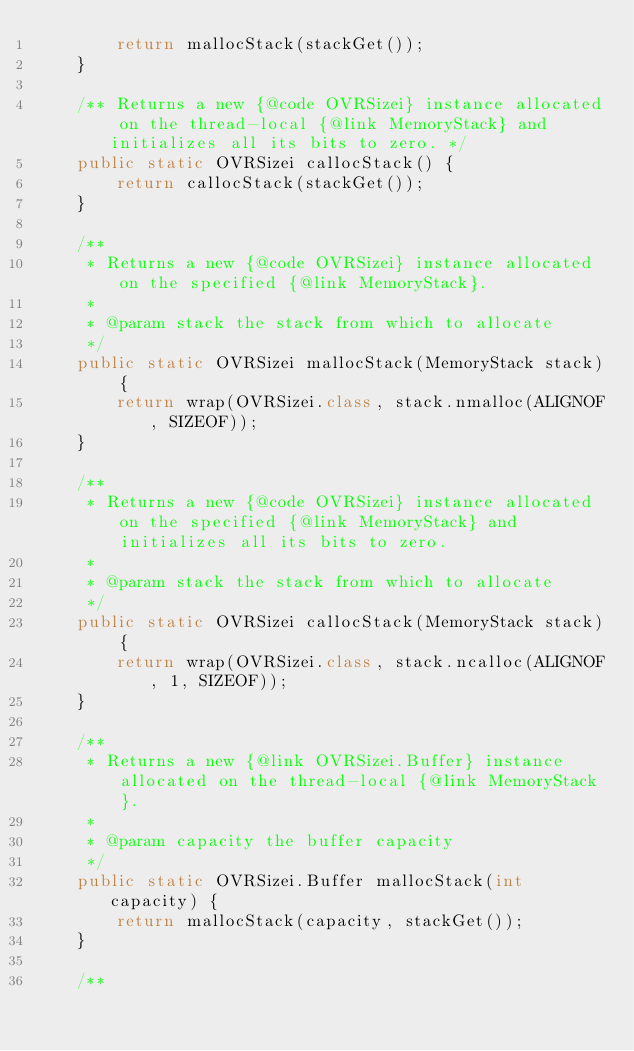Convert code to text. <code><loc_0><loc_0><loc_500><loc_500><_Java_>        return mallocStack(stackGet());
    }

    /** Returns a new {@code OVRSizei} instance allocated on the thread-local {@link MemoryStack} and initializes all its bits to zero. */
    public static OVRSizei callocStack() {
        return callocStack(stackGet());
    }

    /**
     * Returns a new {@code OVRSizei} instance allocated on the specified {@link MemoryStack}.
     *
     * @param stack the stack from which to allocate
     */
    public static OVRSizei mallocStack(MemoryStack stack) {
        return wrap(OVRSizei.class, stack.nmalloc(ALIGNOF, SIZEOF));
    }

    /**
     * Returns a new {@code OVRSizei} instance allocated on the specified {@link MemoryStack} and initializes all its bits to zero.
     *
     * @param stack the stack from which to allocate
     */
    public static OVRSizei callocStack(MemoryStack stack) {
        return wrap(OVRSizei.class, stack.ncalloc(ALIGNOF, 1, SIZEOF));
    }

    /**
     * Returns a new {@link OVRSizei.Buffer} instance allocated on the thread-local {@link MemoryStack}.
     *
     * @param capacity the buffer capacity
     */
    public static OVRSizei.Buffer mallocStack(int capacity) {
        return mallocStack(capacity, stackGet());
    }

    /**</code> 